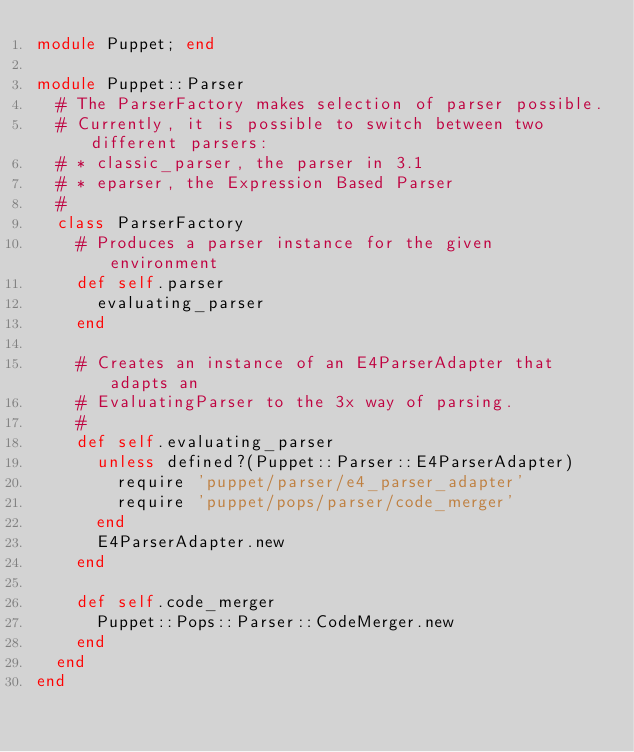Convert code to text. <code><loc_0><loc_0><loc_500><loc_500><_Ruby_>module Puppet; end

module Puppet::Parser
  # The ParserFactory makes selection of parser possible.
  # Currently, it is possible to switch between two different parsers:
  # * classic_parser, the parser in 3.1
  # * eparser, the Expression Based Parser
  #
  class ParserFactory
    # Produces a parser instance for the given environment
    def self.parser
      evaluating_parser
    end

    # Creates an instance of an E4ParserAdapter that adapts an
    # EvaluatingParser to the 3x way of parsing.
    #
    def self.evaluating_parser
      unless defined?(Puppet::Parser::E4ParserAdapter)
        require 'puppet/parser/e4_parser_adapter'
        require 'puppet/pops/parser/code_merger'
      end
      E4ParserAdapter.new
    end

    def self.code_merger
      Puppet::Pops::Parser::CodeMerger.new
    end
  end
end
</code> 